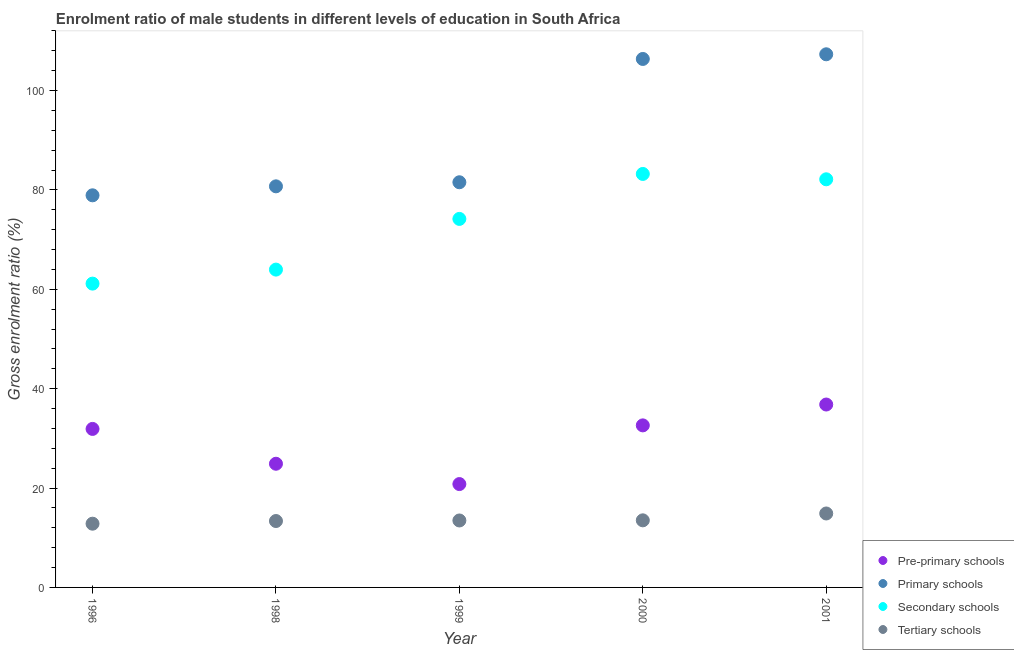Is the number of dotlines equal to the number of legend labels?
Make the answer very short. Yes. What is the gross enrolment ratio(female) in secondary schools in 1999?
Keep it short and to the point. 74.16. Across all years, what is the maximum gross enrolment ratio(female) in pre-primary schools?
Give a very brief answer. 36.81. Across all years, what is the minimum gross enrolment ratio(female) in secondary schools?
Make the answer very short. 61.14. In which year was the gross enrolment ratio(female) in pre-primary schools maximum?
Provide a succinct answer. 2001. What is the total gross enrolment ratio(female) in tertiary schools in the graph?
Give a very brief answer. 68.04. What is the difference between the gross enrolment ratio(female) in primary schools in 1996 and that in 1999?
Your answer should be compact. -2.63. What is the difference between the gross enrolment ratio(female) in pre-primary schools in 1996 and the gross enrolment ratio(female) in primary schools in 1998?
Your answer should be compact. -48.82. What is the average gross enrolment ratio(female) in secondary schools per year?
Your answer should be very brief. 72.92. In the year 2000, what is the difference between the gross enrolment ratio(female) in pre-primary schools and gross enrolment ratio(female) in tertiary schools?
Give a very brief answer. 19.11. What is the ratio of the gross enrolment ratio(female) in secondary schools in 1998 to that in 2000?
Your answer should be compact. 0.77. Is the gross enrolment ratio(female) in primary schools in 1996 less than that in 2000?
Make the answer very short. Yes. Is the difference between the gross enrolment ratio(female) in pre-primary schools in 1996 and 2001 greater than the difference between the gross enrolment ratio(female) in tertiary schools in 1996 and 2001?
Provide a succinct answer. No. What is the difference between the highest and the second highest gross enrolment ratio(female) in tertiary schools?
Your response must be concise. 1.38. What is the difference between the highest and the lowest gross enrolment ratio(female) in primary schools?
Your response must be concise. 28.38. In how many years, is the gross enrolment ratio(female) in primary schools greater than the average gross enrolment ratio(female) in primary schools taken over all years?
Ensure brevity in your answer.  2. Is the sum of the gross enrolment ratio(female) in secondary schools in 1998 and 2000 greater than the maximum gross enrolment ratio(female) in pre-primary schools across all years?
Your answer should be compact. Yes. Is it the case that in every year, the sum of the gross enrolment ratio(female) in tertiary schools and gross enrolment ratio(female) in primary schools is greater than the sum of gross enrolment ratio(female) in secondary schools and gross enrolment ratio(female) in pre-primary schools?
Give a very brief answer. Yes. Does the gross enrolment ratio(female) in primary schools monotonically increase over the years?
Offer a very short reply. Yes. Is the gross enrolment ratio(female) in pre-primary schools strictly greater than the gross enrolment ratio(female) in tertiary schools over the years?
Provide a succinct answer. Yes. How many dotlines are there?
Ensure brevity in your answer.  4. How many years are there in the graph?
Provide a succinct answer. 5. Are the values on the major ticks of Y-axis written in scientific E-notation?
Offer a terse response. No. Does the graph contain any zero values?
Ensure brevity in your answer.  No. Where does the legend appear in the graph?
Offer a terse response. Bottom right. What is the title of the graph?
Your response must be concise. Enrolment ratio of male students in different levels of education in South Africa. Does "Business regulatory environment" appear as one of the legend labels in the graph?
Make the answer very short. No. What is the label or title of the Y-axis?
Your answer should be very brief. Gross enrolment ratio (%). What is the Gross enrolment ratio (%) of Pre-primary schools in 1996?
Offer a terse response. 31.9. What is the Gross enrolment ratio (%) in Primary schools in 1996?
Keep it short and to the point. 78.91. What is the Gross enrolment ratio (%) in Secondary schools in 1996?
Provide a succinct answer. 61.14. What is the Gross enrolment ratio (%) of Tertiary schools in 1996?
Ensure brevity in your answer.  12.83. What is the Gross enrolment ratio (%) in Pre-primary schools in 1998?
Give a very brief answer. 24.89. What is the Gross enrolment ratio (%) in Primary schools in 1998?
Your answer should be very brief. 80.71. What is the Gross enrolment ratio (%) of Secondary schools in 1998?
Your answer should be very brief. 63.96. What is the Gross enrolment ratio (%) of Tertiary schools in 1998?
Provide a short and direct response. 13.36. What is the Gross enrolment ratio (%) in Pre-primary schools in 1999?
Your response must be concise. 20.8. What is the Gross enrolment ratio (%) of Primary schools in 1999?
Keep it short and to the point. 81.53. What is the Gross enrolment ratio (%) in Secondary schools in 1999?
Offer a very short reply. 74.16. What is the Gross enrolment ratio (%) in Tertiary schools in 1999?
Your response must be concise. 13.47. What is the Gross enrolment ratio (%) of Pre-primary schools in 2000?
Give a very brief answer. 32.61. What is the Gross enrolment ratio (%) in Primary schools in 2000?
Offer a terse response. 106.35. What is the Gross enrolment ratio (%) in Secondary schools in 2000?
Offer a terse response. 83.21. What is the Gross enrolment ratio (%) of Tertiary schools in 2000?
Ensure brevity in your answer.  13.5. What is the Gross enrolment ratio (%) in Pre-primary schools in 2001?
Make the answer very short. 36.81. What is the Gross enrolment ratio (%) in Primary schools in 2001?
Offer a terse response. 107.29. What is the Gross enrolment ratio (%) in Secondary schools in 2001?
Keep it short and to the point. 82.13. What is the Gross enrolment ratio (%) in Tertiary schools in 2001?
Make the answer very short. 14.88. Across all years, what is the maximum Gross enrolment ratio (%) in Pre-primary schools?
Provide a succinct answer. 36.81. Across all years, what is the maximum Gross enrolment ratio (%) of Primary schools?
Offer a terse response. 107.29. Across all years, what is the maximum Gross enrolment ratio (%) of Secondary schools?
Give a very brief answer. 83.21. Across all years, what is the maximum Gross enrolment ratio (%) in Tertiary schools?
Ensure brevity in your answer.  14.88. Across all years, what is the minimum Gross enrolment ratio (%) of Pre-primary schools?
Your answer should be compact. 20.8. Across all years, what is the minimum Gross enrolment ratio (%) of Primary schools?
Give a very brief answer. 78.91. Across all years, what is the minimum Gross enrolment ratio (%) of Secondary schools?
Offer a very short reply. 61.14. Across all years, what is the minimum Gross enrolment ratio (%) of Tertiary schools?
Offer a terse response. 12.83. What is the total Gross enrolment ratio (%) in Pre-primary schools in the graph?
Keep it short and to the point. 147. What is the total Gross enrolment ratio (%) in Primary schools in the graph?
Offer a very short reply. 454.79. What is the total Gross enrolment ratio (%) in Secondary schools in the graph?
Offer a terse response. 364.59. What is the total Gross enrolment ratio (%) in Tertiary schools in the graph?
Keep it short and to the point. 68.04. What is the difference between the Gross enrolment ratio (%) of Pre-primary schools in 1996 and that in 1998?
Offer a terse response. 7.01. What is the difference between the Gross enrolment ratio (%) of Primary schools in 1996 and that in 1998?
Offer a very short reply. -1.81. What is the difference between the Gross enrolment ratio (%) of Secondary schools in 1996 and that in 1998?
Your response must be concise. -2.82. What is the difference between the Gross enrolment ratio (%) in Tertiary schools in 1996 and that in 1998?
Offer a terse response. -0.54. What is the difference between the Gross enrolment ratio (%) in Pre-primary schools in 1996 and that in 1999?
Offer a terse response. 11.1. What is the difference between the Gross enrolment ratio (%) of Primary schools in 1996 and that in 1999?
Your answer should be compact. -2.63. What is the difference between the Gross enrolment ratio (%) of Secondary schools in 1996 and that in 1999?
Give a very brief answer. -13.02. What is the difference between the Gross enrolment ratio (%) in Tertiary schools in 1996 and that in 1999?
Provide a short and direct response. -0.65. What is the difference between the Gross enrolment ratio (%) in Pre-primary schools in 1996 and that in 2000?
Provide a succinct answer. -0.71. What is the difference between the Gross enrolment ratio (%) of Primary schools in 1996 and that in 2000?
Your answer should be compact. -27.44. What is the difference between the Gross enrolment ratio (%) in Secondary schools in 1996 and that in 2000?
Offer a very short reply. -22.07. What is the difference between the Gross enrolment ratio (%) of Tertiary schools in 1996 and that in 2000?
Offer a terse response. -0.68. What is the difference between the Gross enrolment ratio (%) in Pre-primary schools in 1996 and that in 2001?
Your response must be concise. -4.91. What is the difference between the Gross enrolment ratio (%) in Primary schools in 1996 and that in 2001?
Your answer should be compact. -28.38. What is the difference between the Gross enrolment ratio (%) in Secondary schools in 1996 and that in 2001?
Your answer should be very brief. -20.99. What is the difference between the Gross enrolment ratio (%) in Tertiary schools in 1996 and that in 2001?
Give a very brief answer. -2.06. What is the difference between the Gross enrolment ratio (%) of Pre-primary schools in 1998 and that in 1999?
Give a very brief answer. 4.09. What is the difference between the Gross enrolment ratio (%) in Primary schools in 1998 and that in 1999?
Provide a short and direct response. -0.82. What is the difference between the Gross enrolment ratio (%) of Secondary schools in 1998 and that in 1999?
Offer a terse response. -10.2. What is the difference between the Gross enrolment ratio (%) in Tertiary schools in 1998 and that in 1999?
Give a very brief answer. -0.11. What is the difference between the Gross enrolment ratio (%) in Pre-primary schools in 1998 and that in 2000?
Give a very brief answer. -7.72. What is the difference between the Gross enrolment ratio (%) in Primary schools in 1998 and that in 2000?
Offer a very short reply. -25.63. What is the difference between the Gross enrolment ratio (%) in Secondary schools in 1998 and that in 2000?
Make the answer very short. -19.25. What is the difference between the Gross enrolment ratio (%) in Tertiary schools in 1998 and that in 2000?
Offer a terse response. -0.14. What is the difference between the Gross enrolment ratio (%) in Pre-primary schools in 1998 and that in 2001?
Give a very brief answer. -11.92. What is the difference between the Gross enrolment ratio (%) in Primary schools in 1998 and that in 2001?
Your answer should be compact. -26.57. What is the difference between the Gross enrolment ratio (%) of Secondary schools in 1998 and that in 2001?
Provide a short and direct response. -18.17. What is the difference between the Gross enrolment ratio (%) of Tertiary schools in 1998 and that in 2001?
Ensure brevity in your answer.  -1.52. What is the difference between the Gross enrolment ratio (%) of Pre-primary schools in 1999 and that in 2000?
Your answer should be very brief. -11.81. What is the difference between the Gross enrolment ratio (%) in Primary schools in 1999 and that in 2000?
Give a very brief answer. -24.81. What is the difference between the Gross enrolment ratio (%) in Secondary schools in 1999 and that in 2000?
Provide a short and direct response. -9.05. What is the difference between the Gross enrolment ratio (%) in Tertiary schools in 1999 and that in 2000?
Your answer should be very brief. -0.03. What is the difference between the Gross enrolment ratio (%) of Pre-primary schools in 1999 and that in 2001?
Make the answer very short. -16.01. What is the difference between the Gross enrolment ratio (%) in Primary schools in 1999 and that in 2001?
Offer a terse response. -25.75. What is the difference between the Gross enrolment ratio (%) of Secondary schools in 1999 and that in 2001?
Give a very brief answer. -7.97. What is the difference between the Gross enrolment ratio (%) of Tertiary schools in 1999 and that in 2001?
Your response must be concise. -1.41. What is the difference between the Gross enrolment ratio (%) in Pre-primary schools in 2000 and that in 2001?
Offer a terse response. -4.2. What is the difference between the Gross enrolment ratio (%) of Primary schools in 2000 and that in 2001?
Offer a terse response. -0.94. What is the difference between the Gross enrolment ratio (%) in Secondary schools in 2000 and that in 2001?
Your answer should be compact. 1.08. What is the difference between the Gross enrolment ratio (%) of Tertiary schools in 2000 and that in 2001?
Your response must be concise. -1.38. What is the difference between the Gross enrolment ratio (%) in Pre-primary schools in 1996 and the Gross enrolment ratio (%) in Primary schools in 1998?
Offer a terse response. -48.82. What is the difference between the Gross enrolment ratio (%) of Pre-primary schools in 1996 and the Gross enrolment ratio (%) of Secondary schools in 1998?
Your answer should be compact. -32.06. What is the difference between the Gross enrolment ratio (%) in Pre-primary schools in 1996 and the Gross enrolment ratio (%) in Tertiary schools in 1998?
Offer a very short reply. 18.53. What is the difference between the Gross enrolment ratio (%) of Primary schools in 1996 and the Gross enrolment ratio (%) of Secondary schools in 1998?
Keep it short and to the point. 14.95. What is the difference between the Gross enrolment ratio (%) of Primary schools in 1996 and the Gross enrolment ratio (%) of Tertiary schools in 1998?
Your answer should be very brief. 65.55. What is the difference between the Gross enrolment ratio (%) of Secondary schools in 1996 and the Gross enrolment ratio (%) of Tertiary schools in 1998?
Your answer should be very brief. 47.77. What is the difference between the Gross enrolment ratio (%) of Pre-primary schools in 1996 and the Gross enrolment ratio (%) of Primary schools in 1999?
Provide a succinct answer. -49.64. What is the difference between the Gross enrolment ratio (%) of Pre-primary schools in 1996 and the Gross enrolment ratio (%) of Secondary schools in 1999?
Keep it short and to the point. -42.26. What is the difference between the Gross enrolment ratio (%) in Pre-primary schools in 1996 and the Gross enrolment ratio (%) in Tertiary schools in 1999?
Give a very brief answer. 18.42. What is the difference between the Gross enrolment ratio (%) of Primary schools in 1996 and the Gross enrolment ratio (%) of Secondary schools in 1999?
Keep it short and to the point. 4.75. What is the difference between the Gross enrolment ratio (%) in Primary schools in 1996 and the Gross enrolment ratio (%) in Tertiary schools in 1999?
Make the answer very short. 65.43. What is the difference between the Gross enrolment ratio (%) in Secondary schools in 1996 and the Gross enrolment ratio (%) in Tertiary schools in 1999?
Your answer should be compact. 47.66. What is the difference between the Gross enrolment ratio (%) of Pre-primary schools in 1996 and the Gross enrolment ratio (%) of Primary schools in 2000?
Your answer should be very brief. -74.45. What is the difference between the Gross enrolment ratio (%) in Pre-primary schools in 1996 and the Gross enrolment ratio (%) in Secondary schools in 2000?
Provide a short and direct response. -51.31. What is the difference between the Gross enrolment ratio (%) of Pre-primary schools in 1996 and the Gross enrolment ratio (%) of Tertiary schools in 2000?
Offer a terse response. 18.39. What is the difference between the Gross enrolment ratio (%) of Primary schools in 1996 and the Gross enrolment ratio (%) of Secondary schools in 2000?
Your response must be concise. -4.3. What is the difference between the Gross enrolment ratio (%) of Primary schools in 1996 and the Gross enrolment ratio (%) of Tertiary schools in 2000?
Make the answer very short. 65.41. What is the difference between the Gross enrolment ratio (%) of Secondary schools in 1996 and the Gross enrolment ratio (%) of Tertiary schools in 2000?
Ensure brevity in your answer.  47.63. What is the difference between the Gross enrolment ratio (%) of Pre-primary schools in 1996 and the Gross enrolment ratio (%) of Primary schools in 2001?
Your answer should be very brief. -75.39. What is the difference between the Gross enrolment ratio (%) of Pre-primary schools in 1996 and the Gross enrolment ratio (%) of Secondary schools in 2001?
Offer a terse response. -50.23. What is the difference between the Gross enrolment ratio (%) in Pre-primary schools in 1996 and the Gross enrolment ratio (%) in Tertiary schools in 2001?
Your answer should be very brief. 17.02. What is the difference between the Gross enrolment ratio (%) of Primary schools in 1996 and the Gross enrolment ratio (%) of Secondary schools in 2001?
Your response must be concise. -3.22. What is the difference between the Gross enrolment ratio (%) of Primary schools in 1996 and the Gross enrolment ratio (%) of Tertiary schools in 2001?
Make the answer very short. 64.03. What is the difference between the Gross enrolment ratio (%) in Secondary schools in 1996 and the Gross enrolment ratio (%) in Tertiary schools in 2001?
Your response must be concise. 46.26. What is the difference between the Gross enrolment ratio (%) of Pre-primary schools in 1998 and the Gross enrolment ratio (%) of Primary schools in 1999?
Offer a terse response. -56.65. What is the difference between the Gross enrolment ratio (%) of Pre-primary schools in 1998 and the Gross enrolment ratio (%) of Secondary schools in 1999?
Keep it short and to the point. -49.27. What is the difference between the Gross enrolment ratio (%) of Pre-primary schools in 1998 and the Gross enrolment ratio (%) of Tertiary schools in 1999?
Make the answer very short. 11.42. What is the difference between the Gross enrolment ratio (%) in Primary schools in 1998 and the Gross enrolment ratio (%) in Secondary schools in 1999?
Your answer should be compact. 6.55. What is the difference between the Gross enrolment ratio (%) of Primary schools in 1998 and the Gross enrolment ratio (%) of Tertiary schools in 1999?
Offer a very short reply. 67.24. What is the difference between the Gross enrolment ratio (%) of Secondary schools in 1998 and the Gross enrolment ratio (%) of Tertiary schools in 1999?
Your answer should be compact. 50.48. What is the difference between the Gross enrolment ratio (%) in Pre-primary schools in 1998 and the Gross enrolment ratio (%) in Primary schools in 2000?
Offer a terse response. -81.46. What is the difference between the Gross enrolment ratio (%) in Pre-primary schools in 1998 and the Gross enrolment ratio (%) in Secondary schools in 2000?
Your answer should be compact. -58.32. What is the difference between the Gross enrolment ratio (%) in Pre-primary schools in 1998 and the Gross enrolment ratio (%) in Tertiary schools in 2000?
Keep it short and to the point. 11.39. What is the difference between the Gross enrolment ratio (%) in Primary schools in 1998 and the Gross enrolment ratio (%) in Secondary schools in 2000?
Your answer should be very brief. -2.49. What is the difference between the Gross enrolment ratio (%) of Primary schools in 1998 and the Gross enrolment ratio (%) of Tertiary schools in 2000?
Offer a very short reply. 67.21. What is the difference between the Gross enrolment ratio (%) in Secondary schools in 1998 and the Gross enrolment ratio (%) in Tertiary schools in 2000?
Offer a very short reply. 50.46. What is the difference between the Gross enrolment ratio (%) in Pre-primary schools in 1998 and the Gross enrolment ratio (%) in Primary schools in 2001?
Offer a very short reply. -82.4. What is the difference between the Gross enrolment ratio (%) in Pre-primary schools in 1998 and the Gross enrolment ratio (%) in Secondary schools in 2001?
Make the answer very short. -57.24. What is the difference between the Gross enrolment ratio (%) in Pre-primary schools in 1998 and the Gross enrolment ratio (%) in Tertiary schools in 2001?
Give a very brief answer. 10.01. What is the difference between the Gross enrolment ratio (%) of Primary schools in 1998 and the Gross enrolment ratio (%) of Secondary schools in 2001?
Provide a short and direct response. -1.42. What is the difference between the Gross enrolment ratio (%) in Primary schools in 1998 and the Gross enrolment ratio (%) in Tertiary schools in 2001?
Ensure brevity in your answer.  65.83. What is the difference between the Gross enrolment ratio (%) in Secondary schools in 1998 and the Gross enrolment ratio (%) in Tertiary schools in 2001?
Offer a very short reply. 49.08. What is the difference between the Gross enrolment ratio (%) in Pre-primary schools in 1999 and the Gross enrolment ratio (%) in Primary schools in 2000?
Your response must be concise. -85.55. What is the difference between the Gross enrolment ratio (%) in Pre-primary schools in 1999 and the Gross enrolment ratio (%) in Secondary schools in 2000?
Offer a very short reply. -62.41. What is the difference between the Gross enrolment ratio (%) of Pre-primary schools in 1999 and the Gross enrolment ratio (%) of Tertiary schools in 2000?
Provide a short and direct response. 7.3. What is the difference between the Gross enrolment ratio (%) of Primary schools in 1999 and the Gross enrolment ratio (%) of Secondary schools in 2000?
Offer a terse response. -1.67. What is the difference between the Gross enrolment ratio (%) of Primary schools in 1999 and the Gross enrolment ratio (%) of Tertiary schools in 2000?
Offer a very short reply. 68.03. What is the difference between the Gross enrolment ratio (%) of Secondary schools in 1999 and the Gross enrolment ratio (%) of Tertiary schools in 2000?
Give a very brief answer. 60.66. What is the difference between the Gross enrolment ratio (%) of Pre-primary schools in 1999 and the Gross enrolment ratio (%) of Primary schools in 2001?
Offer a very short reply. -86.49. What is the difference between the Gross enrolment ratio (%) in Pre-primary schools in 1999 and the Gross enrolment ratio (%) in Secondary schools in 2001?
Offer a terse response. -61.33. What is the difference between the Gross enrolment ratio (%) in Pre-primary schools in 1999 and the Gross enrolment ratio (%) in Tertiary schools in 2001?
Give a very brief answer. 5.92. What is the difference between the Gross enrolment ratio (%) of Primary schools in 1999 and the Gross enrolment ratio (%) of Secondary schools in 2001?
Provide a succinct answer. -0.6. What is the difference between the Gross enrolment ratio (%) of Primary schools in 1999 and the Gross enrolment ratio (%) of Tertiary schools in 2001?
Give a very brief answer. 66.65. What is the difference between the Gross enrolment ratio (%) in Secondary schools in 1999 and the Gross enrolment ratio (%) in Tertiary schools in 2001?
Keep it short and to the point. 59.28. What is the difference between the Gross enrolment ratio (%) of Pre-primary schools in 2000 and the Gross enrolment ratio (%) of Primary schools in 2001?
Your response must be concise. -74.68. What is the difference between the Gross enrolment ratio (%) of Pre-primary schools in 2000 and the Gross enrolment ratio (%) of Secondary schools in 2001?
Make the answer very short. -49.52. What is the difference between the Gross enrolment ratio (%) in Pre-primary schools in 2000 and the Gross enrolment ratio (%) in Tertiary schools in 2001?
Provide a succinct answer. 17.73. What is the difference between the Gross enrolment ratio (%) of Primary schools in 2000 and the Gross enrolment ratio (%) of Secondary schools in 2001?
Your response must be concise. 24.22. What is the difference between the Gross enrolment ratio (%) of Primary schools in 2000 and the Gross enrolment ratio (%) of Tertiary schools in 2001?
Ensure brevity in your answer.  91.47. What is the difference between the Gross enrolment ratio (%) in Secondary schools in 2000 and the Gross enrolment ratio (%) in Tertiary schools in 2001?
Your response must be concise. 68.33. What is the average Gross enrolment ratio (%) of Pre-primary schools per year?
Your response must be concise. 29.4. What is the average Gross enrolment ratio (%) in Primary schools per year?
Make the answer very short. 90.96. What is the average Gross enrolment ratio (%) of Secondary schools per year?
Your answer should be compact. 72.92. What is the average Gross enrolment ratio (%) in Tertiary schools per year?
Offer a very short reply. 13.61. In the year 1996, what is the difference between the Gross enrolment ratio (%) of Pre-primary schools and Gross enrolment ratio (%) of Primary schools?
Your answer should be compact. -47.01. In the year 1996, what is the difference between the Gross enrolment ratio (%) in Pre-primary schools and Gross enrolment ratio (%) in Secondary schools?
Your answer should be compact. -29.24. In the year 1996, what is the difference between the Gross enrolment ratio (%) in Pre-primary schools and Gross enrolment ratio (%) in Tertiary schools?
Your response must be concise. 19.07. In the year 1996, what is the difference between the Gross enrolment ratio (%) in Primary schools and Gross enrolment ratio (%) in Secondary schools?
Provide a succinct answer. 17.77. In the year 1996, what is the difference between the Gross enrolment ratio (%) of Primary schools and Gross enrolment ratio (%) of Tertiary schools?
Your response must be concise. 66.08. In the year 1996, what is the difference between the Gross enrolment ratio (%) in Secondary schools and Gross enrolment ratio (%) in Tertiary schools?
Keep it short and to the point. 48.31. In the year 1998, what is the difference between the Gross enrolment ratio (%) of Pre-primary schools and Gross enrolment ratio (%) of Primary schools?
Provide a succinct answer. -55.83. In the year 1998, what is the difference between the Gross enrolment ratio (%) in Pre-primary schools and Gross enrolment ratio (%) in Secondary schools?
Provide a short and direct response. -39.07. In the year 1998, what is the difference between the Gross enrolment ratio (%) in Pre-primary schools and Gross enrolment ratio (%) in Tertiary schools?
Offer a very short reply. 11.53. In the year 1998, what is the difference between the Gross enrolment ratio (%) of Primary schools and Gross enrolment ratio (%) of Secondary schools?
Provide a short and direct response. 16.76. In the year 1998, what is the difference between the Gross enrolment ratio (%) of Primary schools and Gross enrolment ratio (%) of Tertiary schools?
Your response must be concise. 67.35. In the year 1998, what is the difference between the Gross enrolment ratio (%) of Secondary schools and Gross enrolment ratio (%) of Tertiary schools?
Make the answer very short. 50.6. In the year 1999, what is the difference between the Gross enrolment ratio (%) in Pre-primary schools and Gross enrolment ratio (%) in Primary schools?
Provide a succinct answer. -60.73. In the year 1999, what is the difference between the Gross enrolment ratio (%) in Pre-primary schools and Gross enrolment ratio (%) in Secondary schools?
Offer a terse response. -53.36. In the year 1999, what is the difference between the Gross enrolment ratio (%) in Pre-primary schools and Gross enrolment ratio (%) in Tertiary schools?
Offer a very short reply. 7.33. In the year 1999, what is the difference between the Gross enrolment ratio (%) of Primary schools and Gross enrolment ratio (%) of Secondary schools?
Your response must be concise. 7.37. In the year 1999, what is the difference between the Gross enrolment ratio (%) in Primary schools and Gross enrolment ratio (%) in Tertiary schools?
Your response must be concise. 68.06. In the year 1999, what is the difference between the Gross enrolment ratio (%) in Secondary schools and Gross enrolment ratio (%) in Tertiary schools?
Your answer should be compact. 60.69. In the year 2000, what is the difference between the Gross enrolment ratio (%) in Pre-primary schools and Gross enrolment ratio (%) in Primary schools?
Your answer should be compact. -73.74. In the year 2000, what is the difference between the Gross enrolment ratio (%) of Pre-primary schools and Gross enrolment ratio (%) of Secondary schools?
Make the answer very short. -50.6. In the year 2000, what is the difference between the Gross enrolment ratio (%) in Pre-primary schools and Gross enrolment ratio (%) in Tertiary schools?
Provide a short and direct response. 19.11. In the year 2000, what is the difference between the Gross enrolment ratio (%) in Primary schools and Gross enrolment ratio (%) in Secondary schools?
Provide a succinct answer. 23.14. In the year 2000, what is the difference between the Gross enrolment ratio (%) in Primary schools and Gross enrolment ratio (%) in Tertiary schools?
Give a very brief answer. 92.85. In the year 2000, what is the difference between the Gross enrolment ratio (%) of Secondary schools and Gross enrolment ratio (%) of Tertiary schools?
Provide a succinct answer. 69.71. In the year 2001, what is the difference between the Gross enrolment ratio (%) in Pre-primary schools and Gross enrolment ratio (%) in Primary schools?
Offer a very short reply. -70.48. In the year 2001, what is the difference between the Gross enrolment ratio (%) of Pre-primary schools and Gross enrolment ratio (%) of Secondary schools?
Provide a succinct answer. -45.32. In the year 2001, what is the difference between the Gross enrolment ratio (%) of Pre-primary schools and Gross enrolment ratio (%) of Tertiary schools?
Offer a terse response. 21.93. In the year 2001, what is the difference between the Gross enrolment ratio (%) in Primary schools and Gross enrolment ratio (%) in Secondary schools?
Your answer should be compact. 25.16. In the year 2001, what is the difference between the Gross enrolment ratio (%) in Primary schools and Gross enrolment ratio (%) in Tertiary schools?
Your answer should be very brief. 92.41. In the year 2001, what is the difference between the Gross enrolment ratio (%) of Secondary schools and Gross enrolment ratio (%) of Tertiary schools?
Keep it short and to the point. 67.25. What is the ratio of the Gross enrolment ratio (%) in Pre-primary schools in 1996 to that in 1998?
Keep it short and to the point. 1.28. What is the ratio of the Gross enrolment ratio (%) in Primary schools in 1996 to that in 1998?
Keep it short and to the point. 0.98. What is the ratio of the Gross enrolment ratio (%) of Secondary schools in 1996 to that in 1998?
Provide a short and direct response. 0.96. What is the ratio of the Gross enrolment ratio (%) in Tertiary schools in 1996 to that in 1998?
Offer a terse response. 0.96. What is the ratio of the Gross enrolment ratio (%) in Pre-primary schools in 1996 to that in 1999?
Keep it short and to the point. 1.53. What is the ratio of the Gross enrolment ratio (%) of Primary schools in 1996 to that in 1999?
Your answer should be compact. 0.97. What is the ratio of the Gross enrolment ratio (%) in Secondary schools in 1996 to that in 1999?
Your answer should be very brief. 0.82. What is the ratio of the Gross enrolment ratio (%) of Tertiary schools in 1996 to that in 1999?
Your answer should be compact. 0.95. What is the ratio of the Gross enrolment ratio (%) of Pre-primary schools in 1996 to that in 2000?
Your answer should be very brief. 0.98. What is the ratio of the Gross enrolment ratio (%) in Primary schools in 1996 to that in 2000?
Give a very brief answer. 0.74. What is the ratio of the Gross enrolment ratio (%) of Secondary schools in 1996 to that in 2000?
Your response must be concise. 0.73. What is the ratio of the Gross enrolment ratio (%) in Tertiary schools in 1996 to that in 2000?
Keep it short and to the point. 0.95. What is the ratio of the Gross enrolment ratio (%) in Pre-primary schools in 1996 to that in 2001?
Offer a very short reply. 0.87. What is the ratio of the Gross enrolment ratio (%) of Primary schools in 1996 to that in 2001?
Ensure brevity in your answer.  0.74. What is the ratio of the Gross enrolment ratio (%) of Secondary schools in 1996 to that in 2001?
Your answer should be very brief. 0.74. What is the ratio of the Gross enrolment ratio (%) in Tertiary schools in 1996 to that in 2001?
Offer a very short reply. 0.86. What is the ratio of the Gross enrolment ratio (%) of Pre-primary schools in 1998 to that in 1999?
Keep it short and to the point. 1.2. What is the ratio of the Gross enrolment ratio (%) of Secondary schools in 1998 to that in 1999?
Provide a short and direct response. 0.86. What is the ratio of the Gross enrolment ratio (%) in Pre-primary schools in 1998 to that in 2000?
Your response must be concise. 0.76. What is the ratio of the Gross enrolment ratio (%) in Primary schools in 1998 to that in 2000?
Offer a very short reply. 0.76. What is the ratio of the Gross enrolment ratio (%) of Secondary schools in 1998 to that in 2000?
Your response must be concise. 0.77. What is the ratio of the Gross enrolment ratio (%) of Tertiary schools in 1998 to that in 2000?
Your answer should be compact. 0.99. What is the ratio of the Gross enrolment ratio (%) in Pre-primary schools in 1998 to that in 2001?
Your response must be concise. 0.68. What is the ratio of the Gross enrolment ratio (%) in Primary schools in 1998 to that in 2001?
Your answer should be very brief. 0.75. What is the ratio of the Gross enrolment ratio (%) of Secondary schools in 1998 to that in 2001?
Make the answer very short. 0.78. What is the ratio of the Gross enrolment ratio (%) of Tertiary schools in 1998 to that in 2001?
Provide a short and direct response. 0.9. What is the ratio of the Gross enrolment ratio (%) of Pre-primary schools in 1999 to that in 2000?
Make the answer very short. 0.64. What is the ratio of the Gross enrolment ratio (%) in Primary schools in 1999 to that in 2000?
Provide a succinct answer. 0.77. What is the ratio of the Gross enrolment ratio (%) in Secondary schools in 1999 to that in 2000?
Keep it short and to the point. 0.89. What is the ratio of the Gross enrolment ratio (%) in Tertiary schools in 1999 to that in 2000?
Keep it short and to the point. 1. What is the ratio of the Gross enrolment ratio (%) in Pre-primary schools in 1999 to that in 2001?
Offer a very short reply. 0.57. What is the ratio of the Gross enrolment ratio (%) of Primary schools in 1999 to that in 2001?
Your answer should be very brief. 0.76. What is the ratio of the Gross enrolment ratio (%) of Secondary schools in 1999 to that in 2001?
Your answer should be very brief. 0.9. What is the ratio of the Gross enrolment ratio (%) of Tertiary schools in 1999 to that in 2001?
Your answer should be very brief. 0.91. What is the ratio of the Gross enrolment ratio (%) in Pre-primary schools in 2000 to that in 2001?
Offer a terse response. 0.89. What is the ratio of the Gross enrolment ratio (%) of Secondary schools in 2000 to that in 2001?
Your answer should be very brief. 1.01. What is the ratio of the Gross enrolment ratio (%) of Tertiary schools in 2000 to that in 2001?
Keep it short and to the point. 0.91. What is the difference between the highest and the second highest Gross enrolment ratio (%) in Pre-primary schools?
Your answer should be compact. 4.2. What is the difference between the highest and the second highest Gross enrolment ratio (%) of Primary schools?
Your answer should be very brief. 0.94. What is the difference between the highest and the second highest Gross enrolment ratio (%) in Tertiary schools?
Offer a terse response. 1.38. What is the difference between the highest and the lowest Gross enrolment ratio (%) of Pre-primary schools?
Offer a terse response. 16.01. What is the difference between the highest and the lowest Gross enrolment ratio (%) of Primary schools?
Your answer should be very brief. 28.38. What is the difference between the highest and the lowest Gross enrolment ratio (%) in Secondary schools?
Offer a terse response. 22.07. What is the difference between the highest and the lowest Gross enrolment ratio (%) in Tertiary schools?
Your answer should be compact. 2.06. 